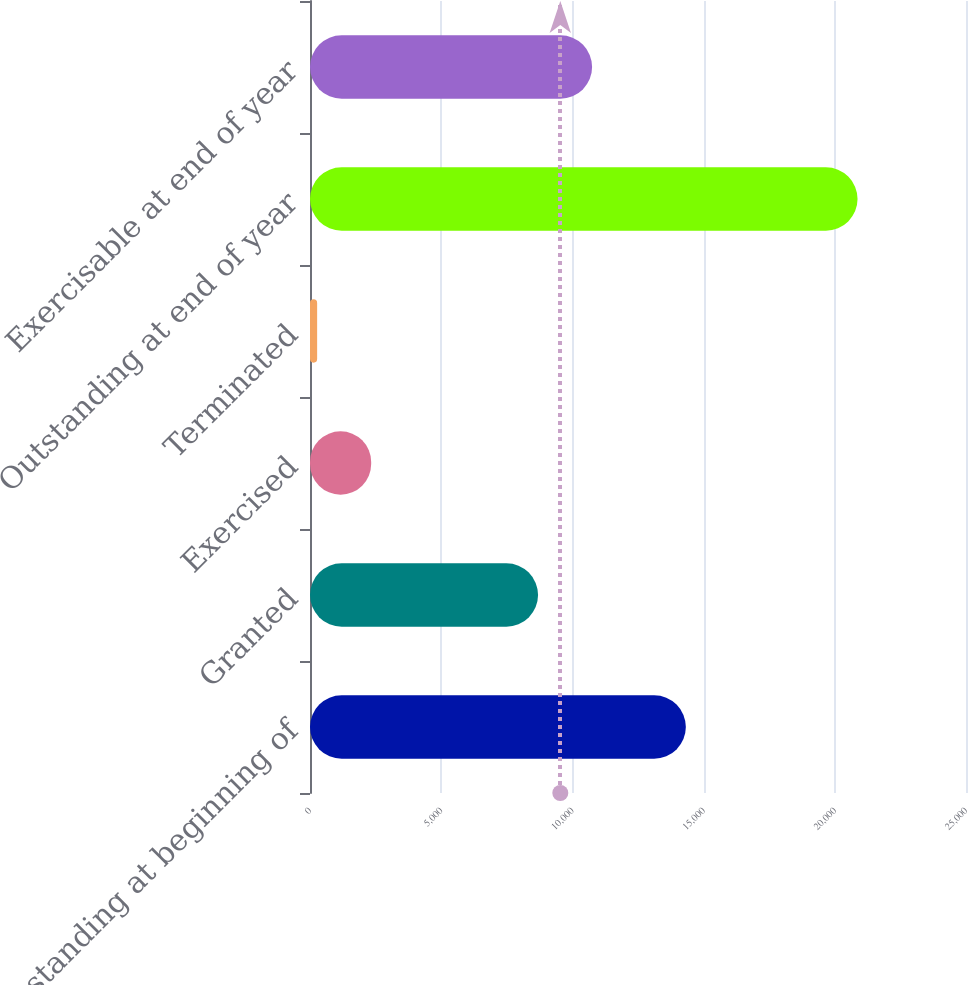Convert chart. <chart><loc_0><loc_0><loc_500><loc_500><bar_chart><fcel>Outstanding at beginning of<fcel>Granted<fcel>Exercised<fcel>Terminated<fcel>Outstanding at end of year<fcel>Exercisable at end of year<nl><fcel>14323<fcel>8691<fcel>2331.5<fcel>272<fcel>20867<fcel>10750.5<nl></chart> 